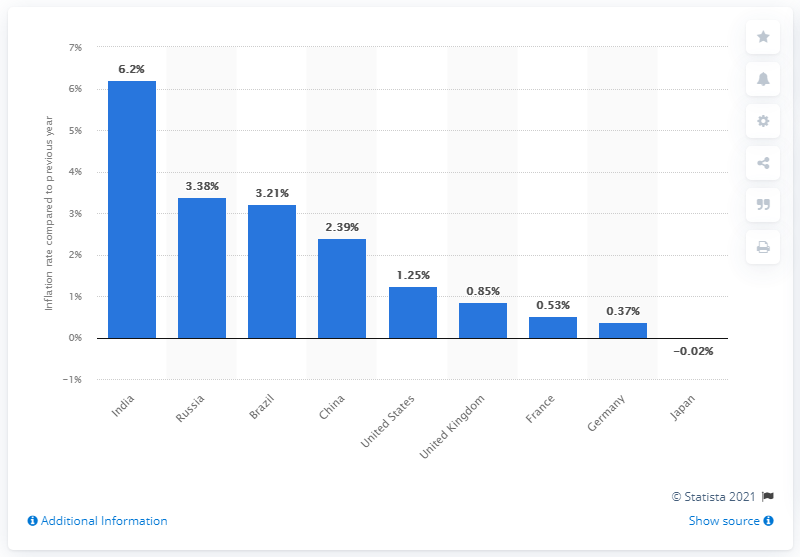Give some essential details in this illustration. In 2020, the inflation rate in China was 2.39%. 